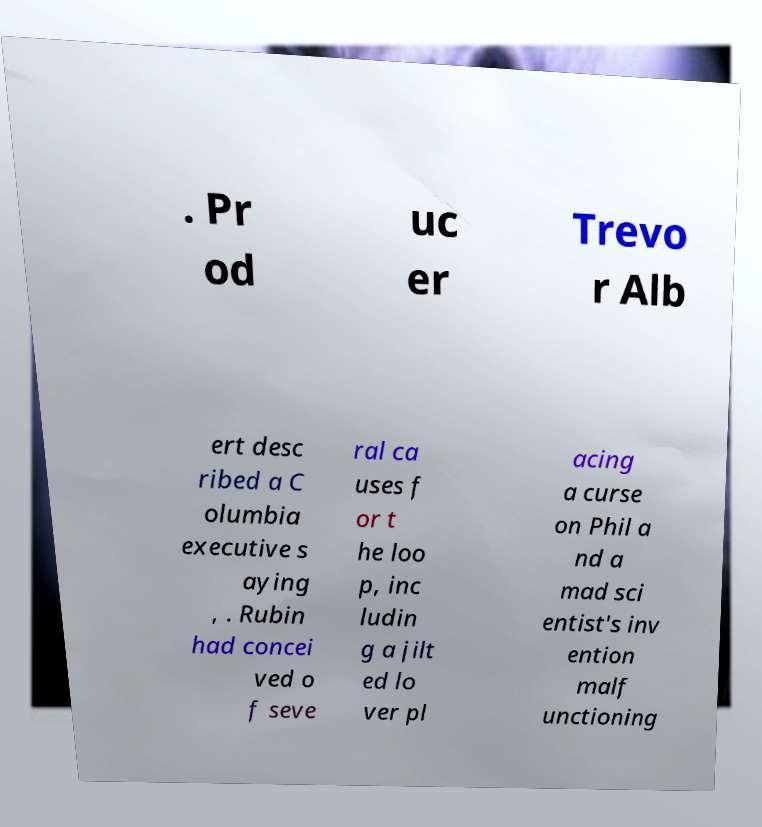Please identify and transcribe the text found in this image. . Pr od uc er Trevo r Alb ert desc ribed a C olumbia executive s aying , . Rubin had concei ved o f seve ral ca uses f or t he loo p, inc ludin g a jilt ed lo ver pl acing a curse on Phil a nd a mad sci entist's inv ention malf unctioning 